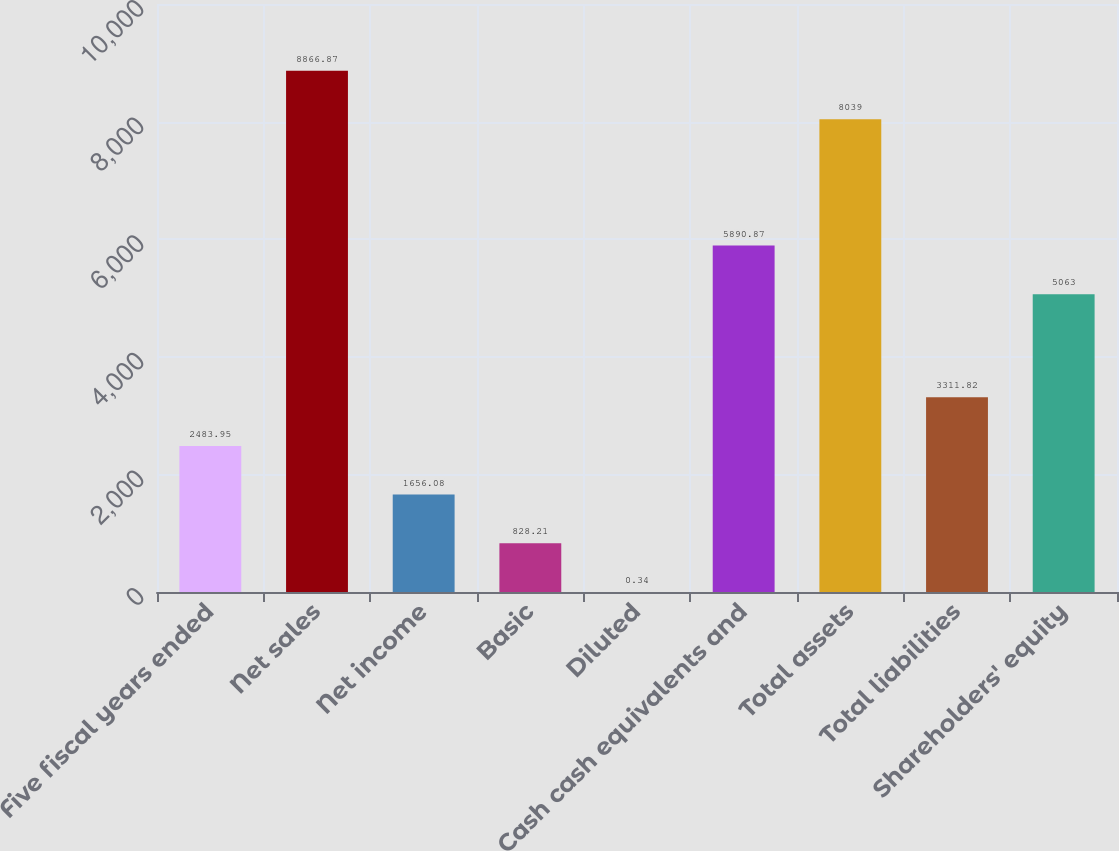Convert chart to OTSL. <chart><loc_0><loc_0><loc_500><loc_500><bar_chart><fcel>Five fiscal years ended<fcel>Net sales<fcel>Net income<fcel>Basic<fcel>Diluted<fcel>Cash cash equivalents and<fcel>Total assets<fcel>Total liabilities<fcel>Shareholders' equity<nl><fcel>2483.95<fcel>8866.87<fcel>1656.08<fcel>828.21<fcel>0.34<fcel>5890.87<fcel>8039<fcel>3311.82<fcel>5063<nl></chart> 